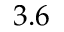<formula> <loc_0><loc_0><loc_500><loc_500>3 . 6</formula> 